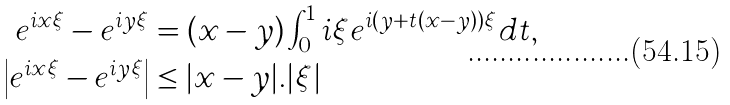Convert formula to latex. <formula><loc_0><loc_0><loc_500><loc_500>e ^ { i x \xi } - e ^ { i y \xi } & = ( x - y ) \int _ { 0 } ^ { 1 } i \xi e ^ { i ( y + t ( x - y ) ) \xi } d t , \\ \left | e ^ { i x \xi } - e ^ { i y \xi } \right | & \leq | x - y | . | \xi |</formula> 